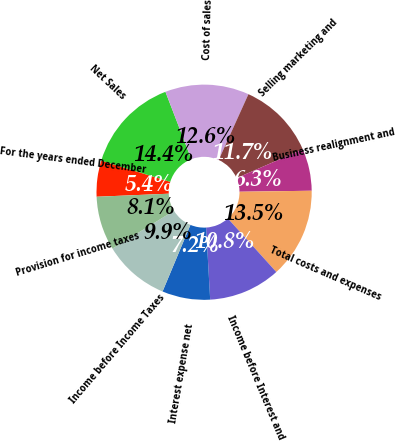Convert chart to OTSL. <chart><loc_0><loc_0><loc_500><loc_500><pie_chart><fcel>For the years ended December<fcel>Net Sales<fcel>Cost of sales<fcel>Selling marketing and<fcel>Business realignment and<fcel>Total costs and expenses<fcel>Income before Interest and<fcel>Interest expense net<fcel>Income before Income Taxes<fcel>Provision for income taxes<nl><fcel>5.41%<fcel>14.41%<fcel>12.61%<fcel>11.71%<fcel>6.31%<fcel>13.51%<fcel>10.81%<fcel>7.21%<fcel>9.91%<fcel>8.11%<nl></chart> 